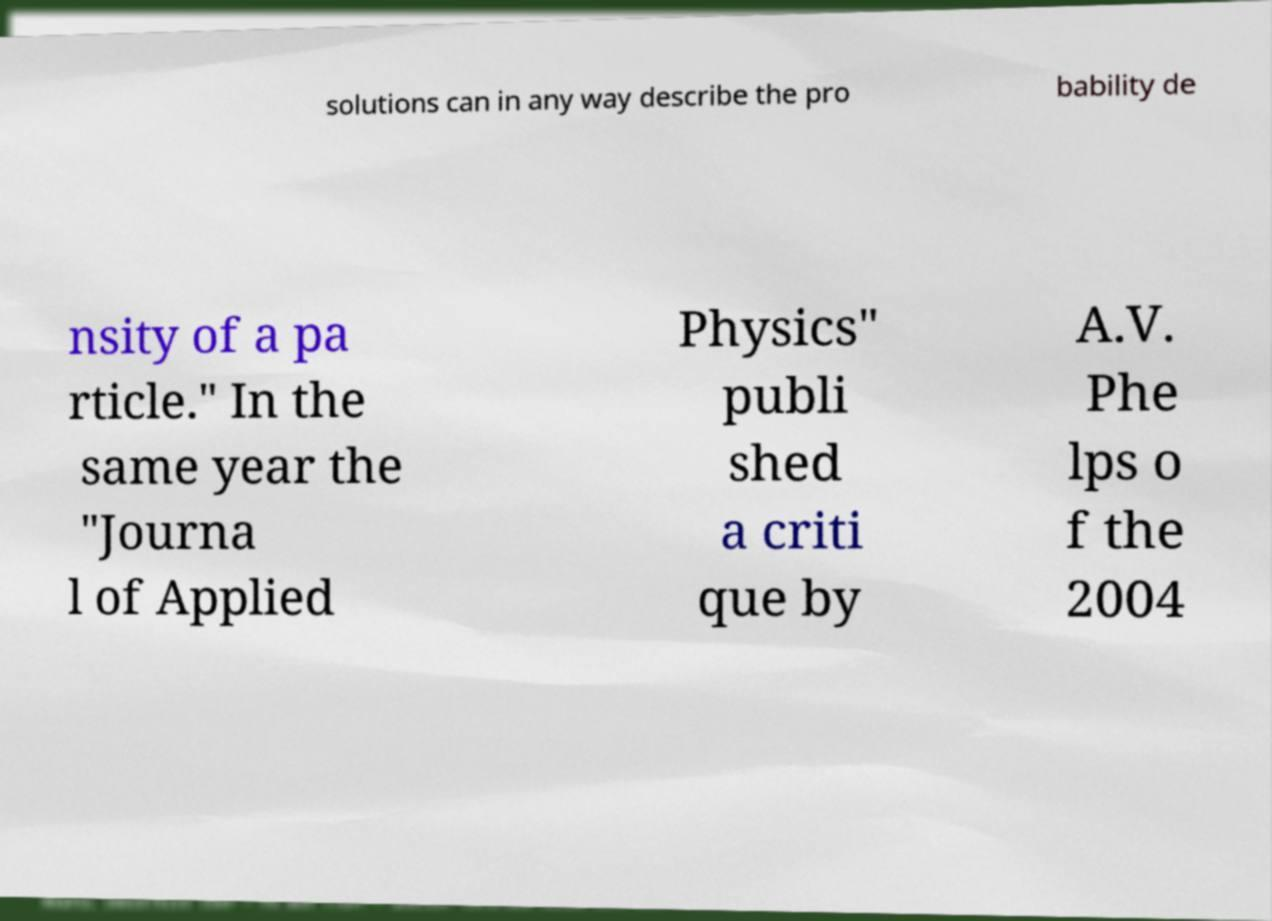What messages or text are displayed in this image? I need them in a readable, typed format. solutions can in any way describe the pro bability de nsity of a pa rticle." In the same year the "Journa l of Applied Physics" publi shed a criti que by A.V. Phe lps o f the 2004 